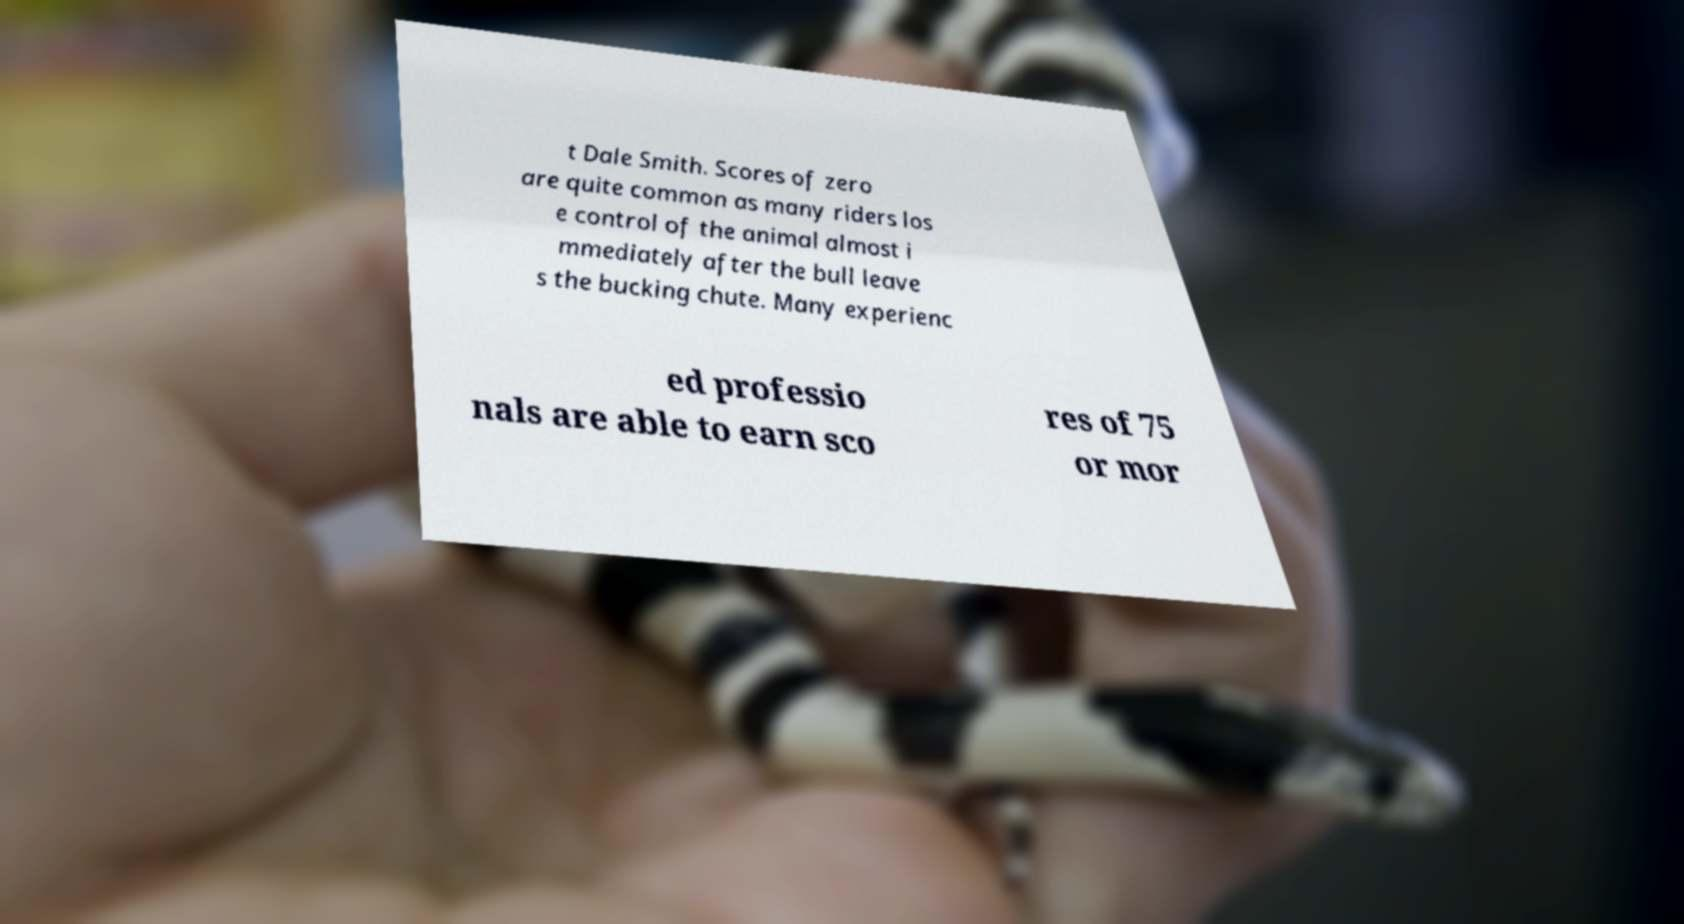For documentation purposes, I need the text within this image transcribed. Could you provide that? t Dale Smith. Scores of zero are quite common as many riders los e control of the animal almost i mmediately after the bull leave s the bucking chute. Many experienc ed professio nals are able to earn sco res of 75 or mor 